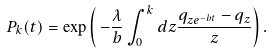Convert formula to latex. <formula><loc_0><loc_0><loc_500><loc_500>P _ { k } ( t ) = \exp \left ( \, - \frac { \lambda } { b } \int _ { 0 } ^ { k } d z \frac { q _ { z e ^ { - b t } } - q _ { z } } { z } \right ) .</formula> 